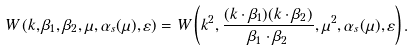<formula> <loc_0><loc_0><loc_500><loc_500>W \left ( k , \beta _ { 1 } , \beta _ { 2 } , \mu , \alpha _ { s } ( \mu ) , \varepsilon \right ) = W \left ( k ^ { 2 } , \frac { ( k \cdot \beta _ { 1 } ) ( k \cdot \beta _ { 2 } ) } { \beta _ { 1 } \cdot \beta _ { 2 } } , \mu ^ { 2 } , \alpha _ { s } ( \mu ) , \varepsilon \right ) .</formula> 